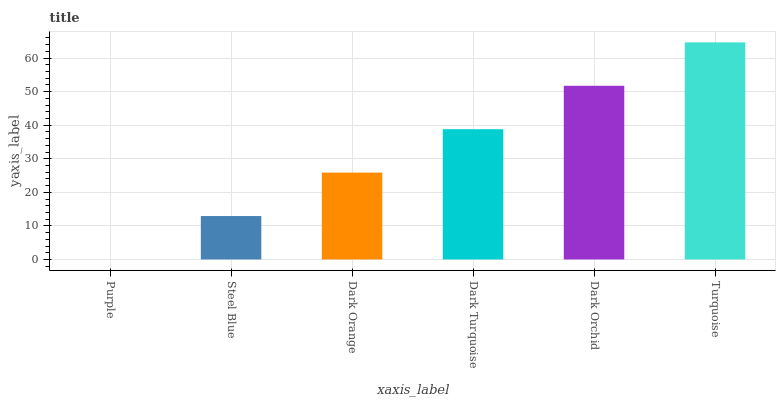Is Purple the minimum?
Answer yes or no. Yes. Is Turquoise the maximum?
Answer yes or no. Yes. Is Steel Blue the minimum?
Answer yes or no. No. Is Steel Blue the maximum?
Answer yes or no. No. Is Steel Blue greater than Purple?
Answer yes or no. Yes. Is Purple less than Steel Blue?
Answer yes or no. Yes. Is Purple greater than Steel Blue?
Answer yes or no. No. Is Steel Blue less than Purple?
Answer yes or no. No. Is Dark Turquoise the high median?
Answer yes or no. Yes. Is Dark Orange the low median?
Answer yes or no. Yes. Is Dark Orange the high median?
Answer yes or no. No. Is Dark Orchid the low median?
Answer yes or no. No. 